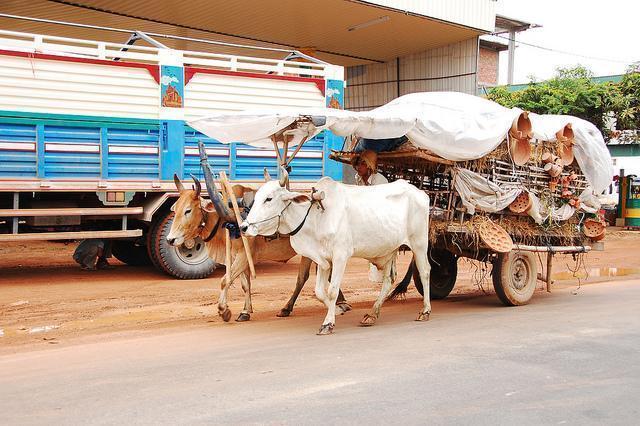What are the bulls doing?
Indicate the correct response by choosing from the four available options to answer the question.
Options: Sleeping, resting, grazing, working. Working. 